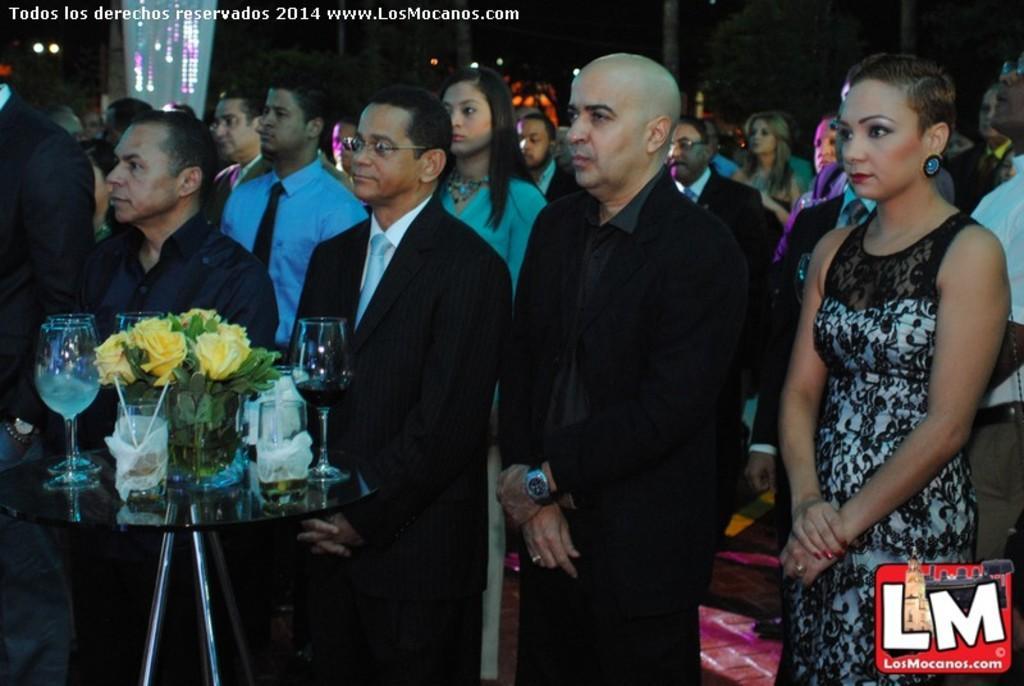Could you give a brief overview of what you see in this image? In this image we can see a group of people standing on the ground. In the foreground of the image we can see flowers and leaves in vase and glasses placed on a table. In the background, we can see some lights and trees. 